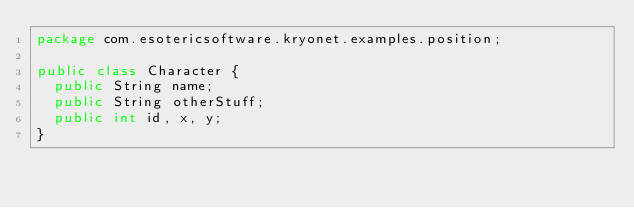Convert code to text. <code><loc_0><loc_0><loc_500><loc_500><_Java_>package com.esotericsoftware.kryonet.examples.position;

public class Character {
	public String name;
	public String otherStuff;
	public int id, x, y;
}
</code> 